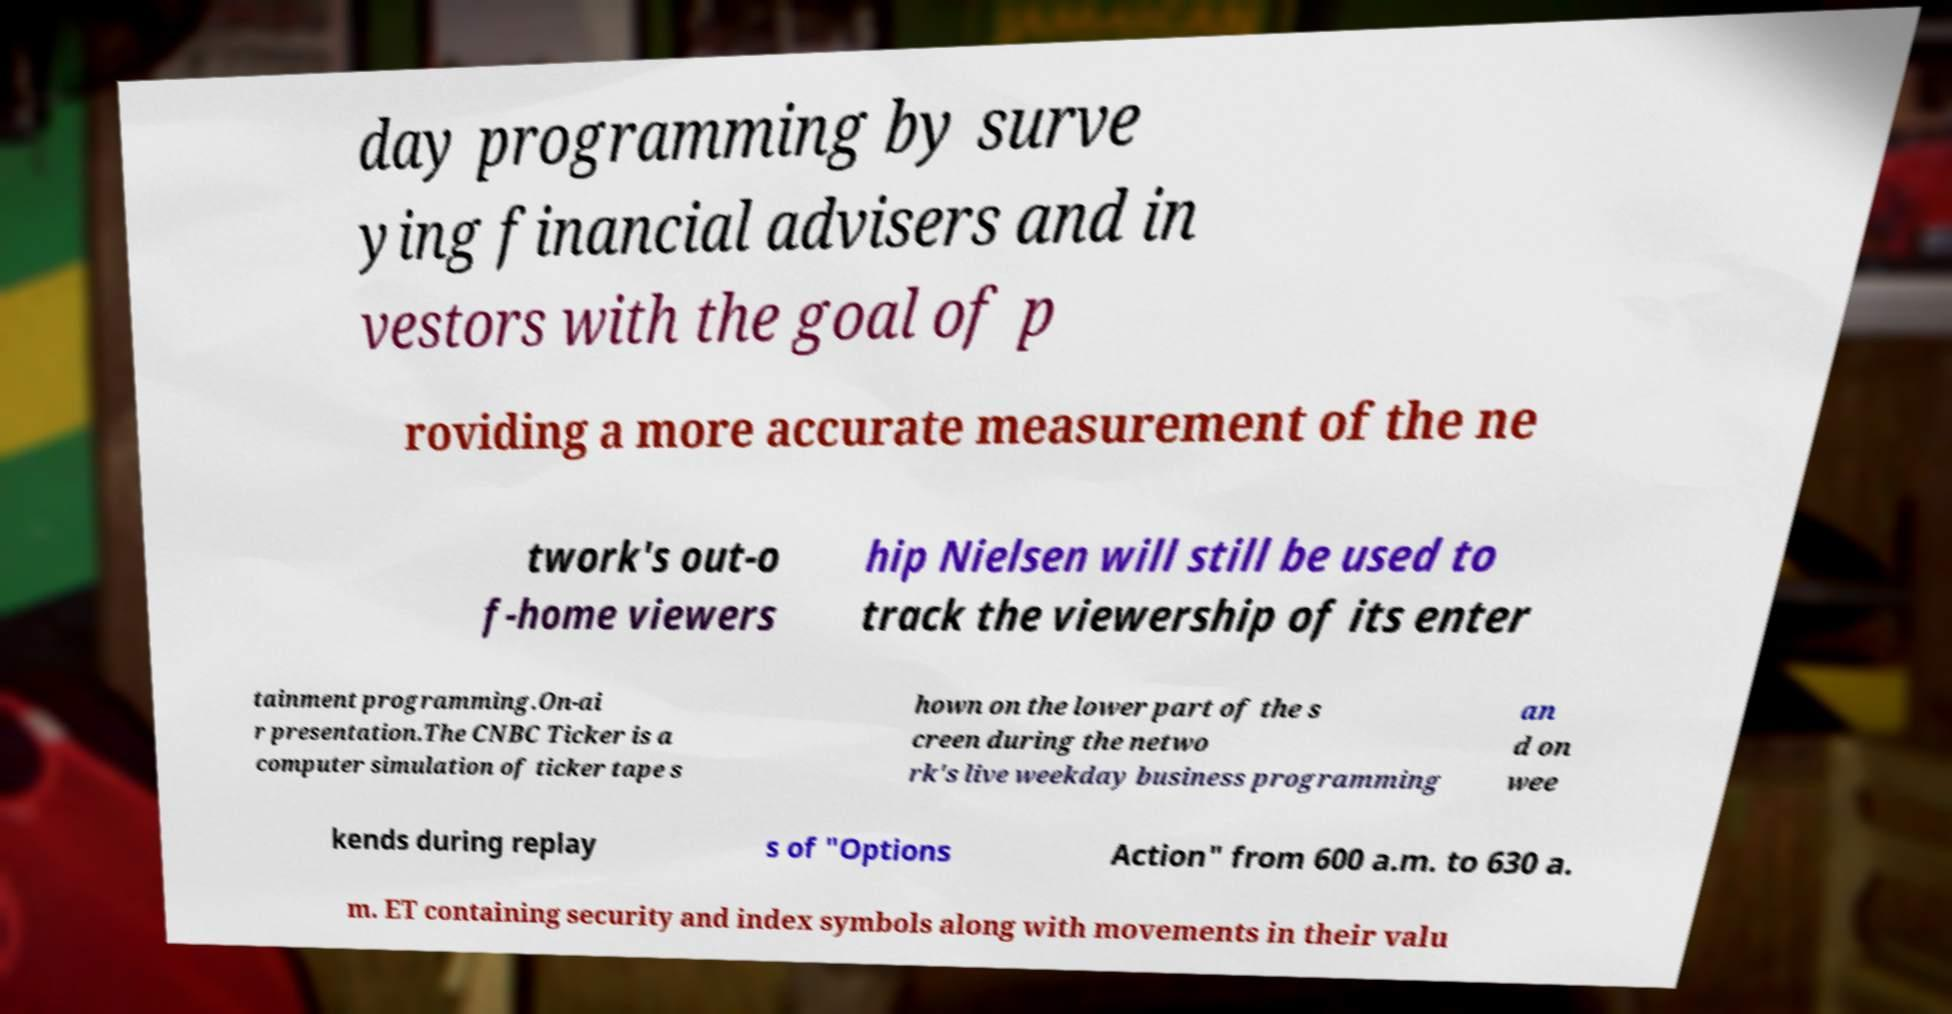I need the written content from this picture converted into text. Can you do that? day programming by surve ying financial advisers and in vestors with the goal of p roviding a more accurate measurement of the ne twork's out-o f-home viewers hip Nielsen will still be used to track the viewership of its enter tainment programming.On-ai r presentation.The CNBC Ticker is a computer simulation of ticker tape s hown on the lower part of the s creen during the netwo rk's live weekday business programming an d on wee kends during replay s of "Options Action" from 600 a.m. to 630 a. m. ET containing security and index symbols along with movements in their valu 